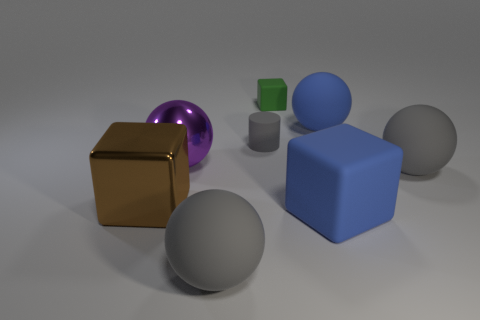Subtract all cyan balls. Subtract all red cylinders. How many balls are left? 4 Add 2 blue cubes. How many objects exist? 10 Subtract all cubes. How many objects are left? 5 Subtract all tiny green cubes. Subtract all big gray matte objects. How many objects are left? 5 Add 1 large blue matte spheres. How many large blue matte spheres are left? 2 Add 3 large matte blocks. How many large matte blocks exist? 4 Subtract 0 brown spheres. How many objects are left? 8 